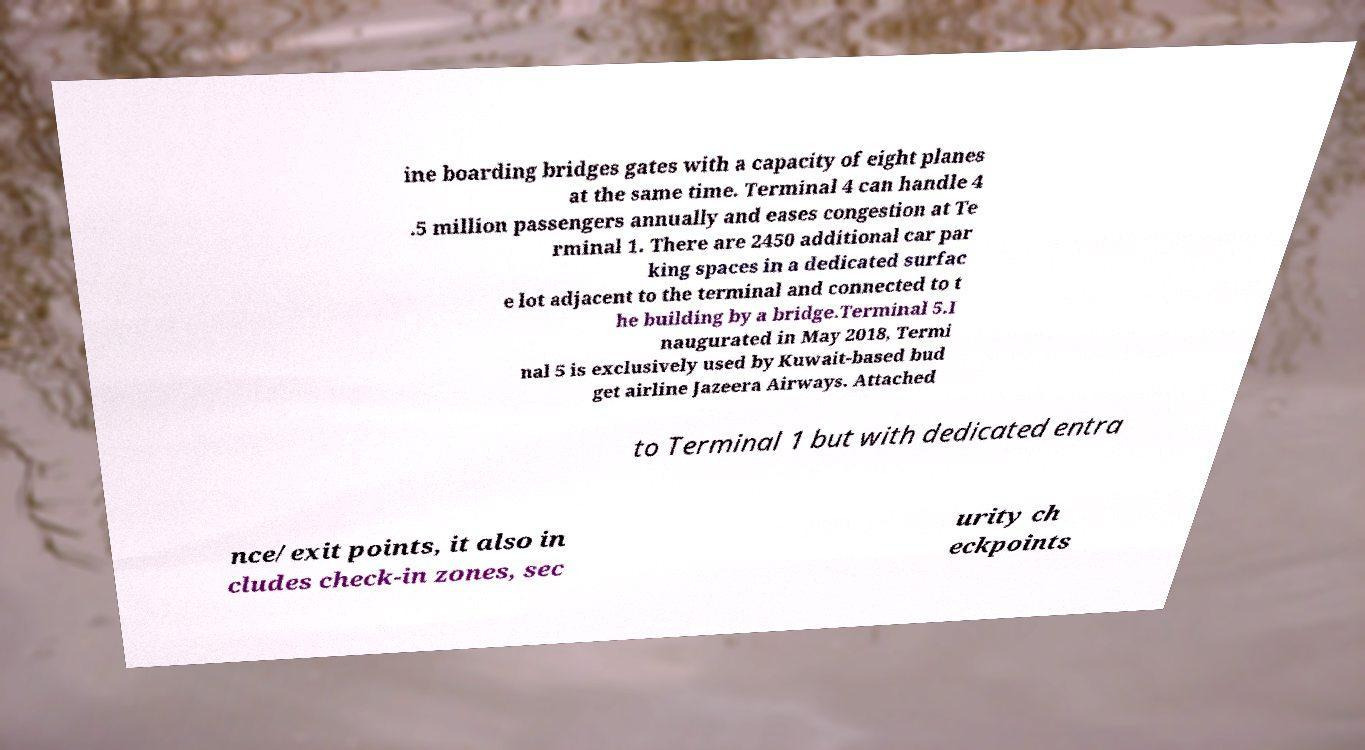Can you read and provide the text displayed in the image?This photo seems to have some interesting text. Can you extract and type it out for me? ine boarding bridges gates with a capacity of eight planes at the same time. Terminal 4 can handle 4 .5 million passengers annually and eases congestion at Te rminal 1. There are 2450 additional car par king spaces in a dedicated surfac e lot adjacent to the terminal and connected to t he building by a bridge.Terminal 5.I naugurated in May 2018, Termi nal 5 is exclusively used by Kuwait-based bud get airline Jazeera Airways. Attached to Terminal 1 but with dedicated entra nce/exit points, it also in cludes check-in zones, sec urity ch eckpoints 